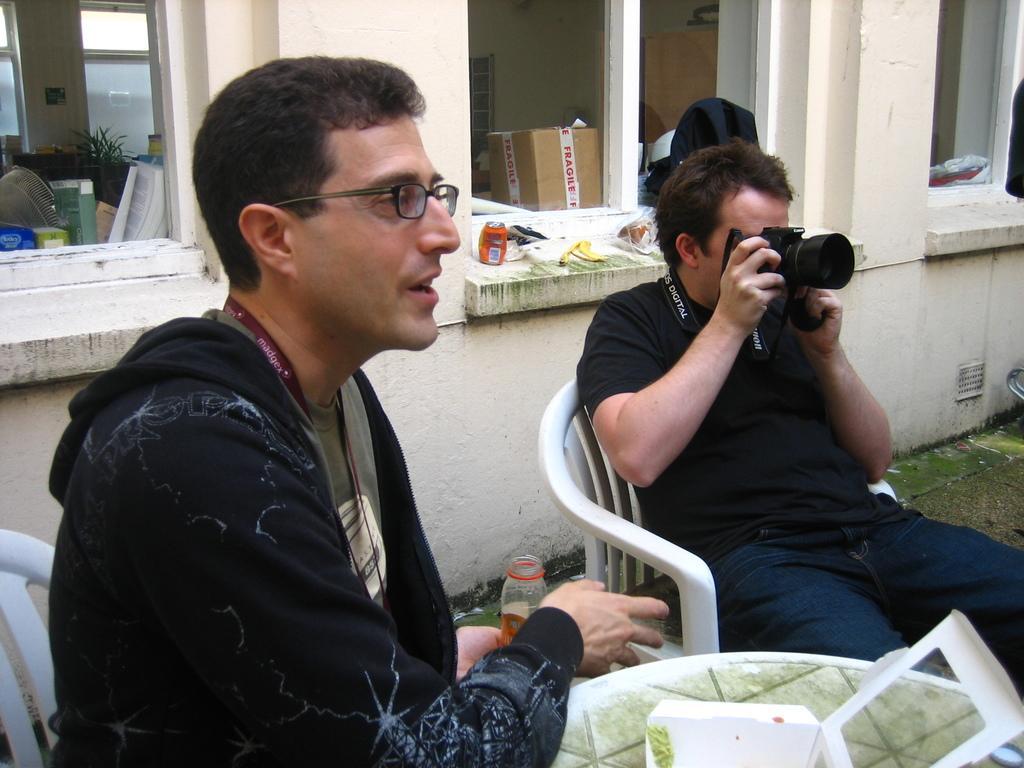How would you summarize this image in a sentence or two? In the foreground of the picture there are people, chairs, table, box, drink and a camera. In the center of the picture there are windows and other objects. In the background there are boxes, plants, windows and other objects. 